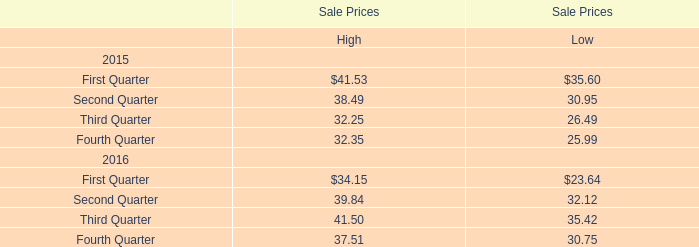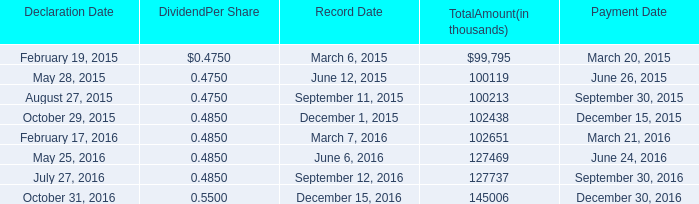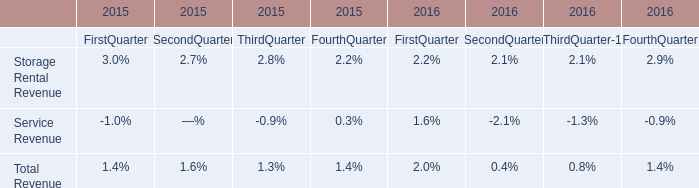If High for Sale Prices in Third Quarter develops with the same increasing rate in 2016, what will it reach in 2017? 
Computations: (41.50 * (1 + ((41.50 - 32.25) / 32.25)))
Answer: 53.4031. 